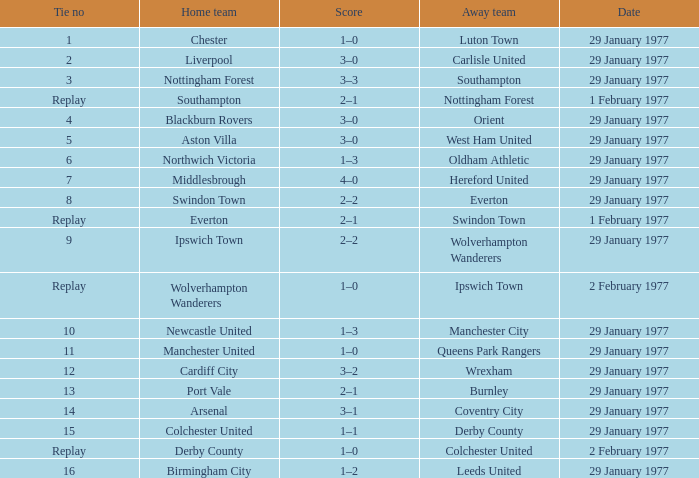What is the tally in the liverpool home match? 3–0. 